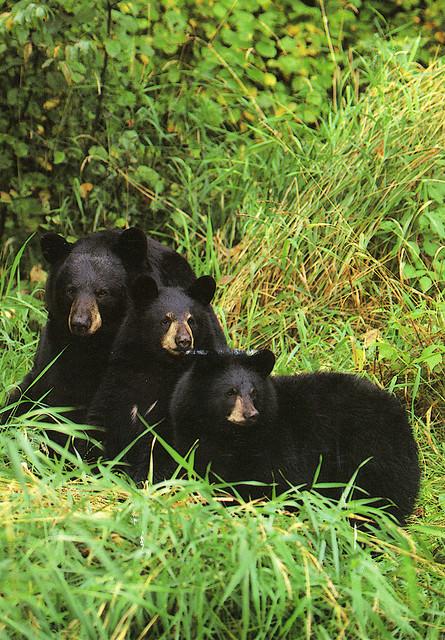How many bears are in this photo?
Concise answer only. 3. Are these fully grown bears?
Write a very short answer. No. Are these grizzly bears?
Keep it brief. No. Do the animals in the picture depict a family unit?
Answer briefly. Yes. How many bears are there?
Concise answer only. 3. 